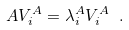<formula> <loc_0><loc_0><loc_500><loc_500>A V ^ { A } _ { i } = \lambda ^ { A } _ { i } V ^ { A } _ { i } \ .</formula> 